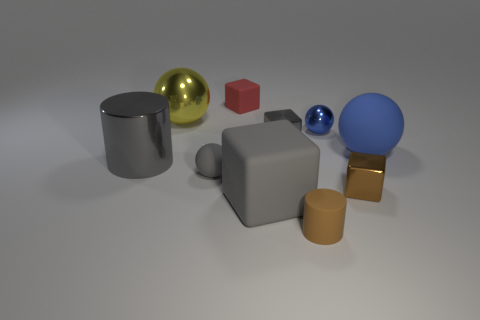Subtract all yellow spheres. How many spheres are left? 3 Subtract all large yellow balls. How many balls are left? 3 Subtract 2 blue spheres. How many objects are left? 8 Subtract all cylinders. How many objects are left? 8 Subtract 3 spheres. How many spheres are left? 1 Subtract all brown cubes. Subtract all gray spheres. How many cubes are left? 3 Subtract all cyan blocks. How many purple balls are left? 0 Subtract all small red matte blocks. Subtract all large rubber objects. How many objects are left? 7 Add 4 small red things. How many small red things are left? 5 Add 3 gray matte things. How many gray matte things exist? 5 